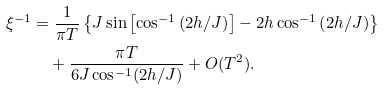Convert formula to latex. <formula><loc_0><loc_0><loc_500><loc_500>\xi ^ { - 1 } & = \frac { 1 } { \pi T } \left \{ J \sin \left [ \cos ^ { - 1 } \left ( 2 h / J \right ) \right ] - 2 h \cos ^ { - 1 } \left ( 2 h / J \right ) \right \} \\ & \quad + \frac { \pi T } { 6 J \cos ^ { - 1 } ( 2 h / J ) } + O ( T ^ { 2 } ) .</formula> 